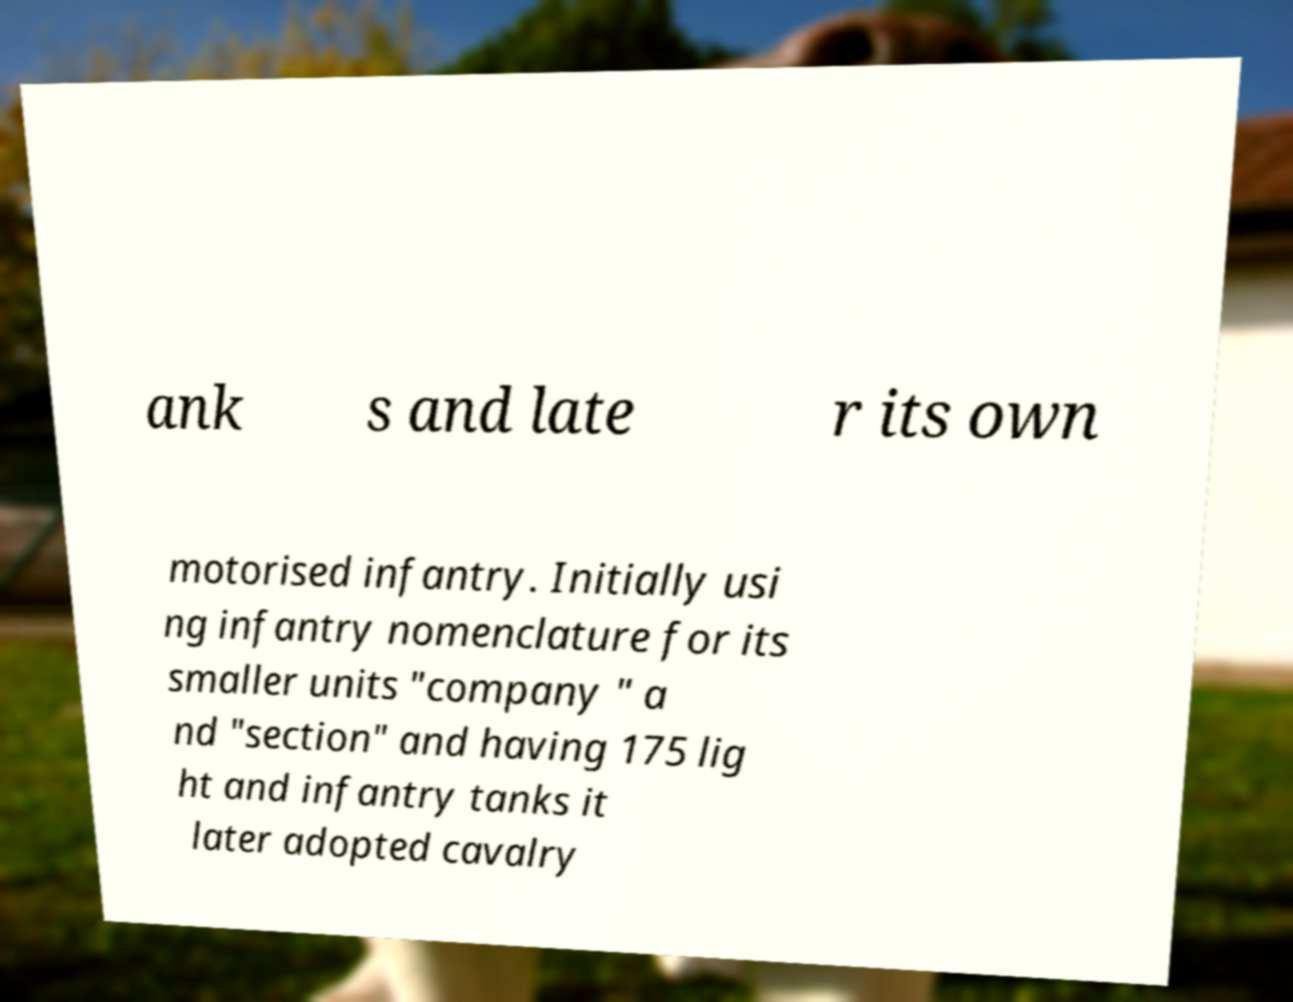What messages or text are displayed in this image? I need them in a readable, typed format. ank s and late r its own motorised infantry. Initially usi ng infantry nomenclature for its smaller units "company " a nd "section" and having 175 lig ht and infantry tanks it later adopted cavalry 